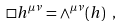Convert formula to latex. <formula><loc_0><loc_0><loc_500><loc_500>\Box h ^ { \mu \nu } = \wedge ^ { \mu \nu } ( h ) \ ,</formula> 